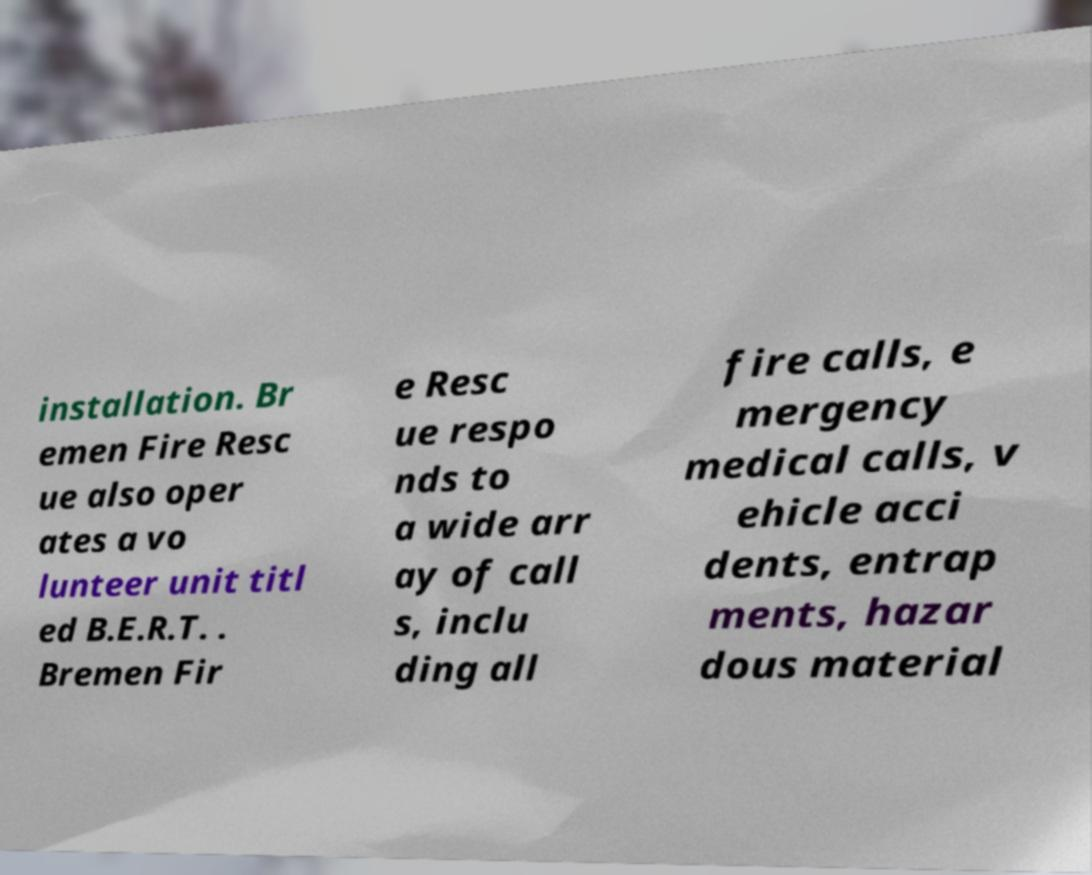Can you accurately transcribe the text from the provided image for me? installation. Br emen Fire Resc ue also oper ates a vo lunteer unit titl ed B.E.R.T. . Bremen Fir e Resc ue respo nds to a wide arr ay of call s, inclu ding all fire calls, e mergency medical calls, v ehicle acci dents, entrap ments, hazar dous material 